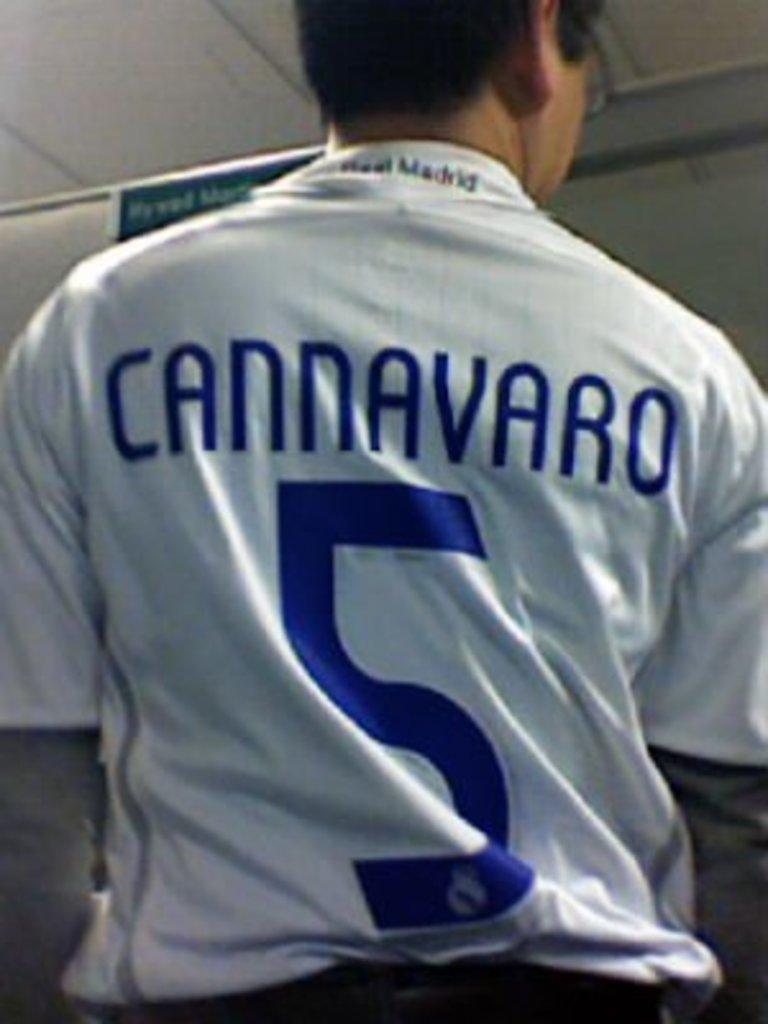What is the number on the jersey?
Give a very brief answer. 5. 